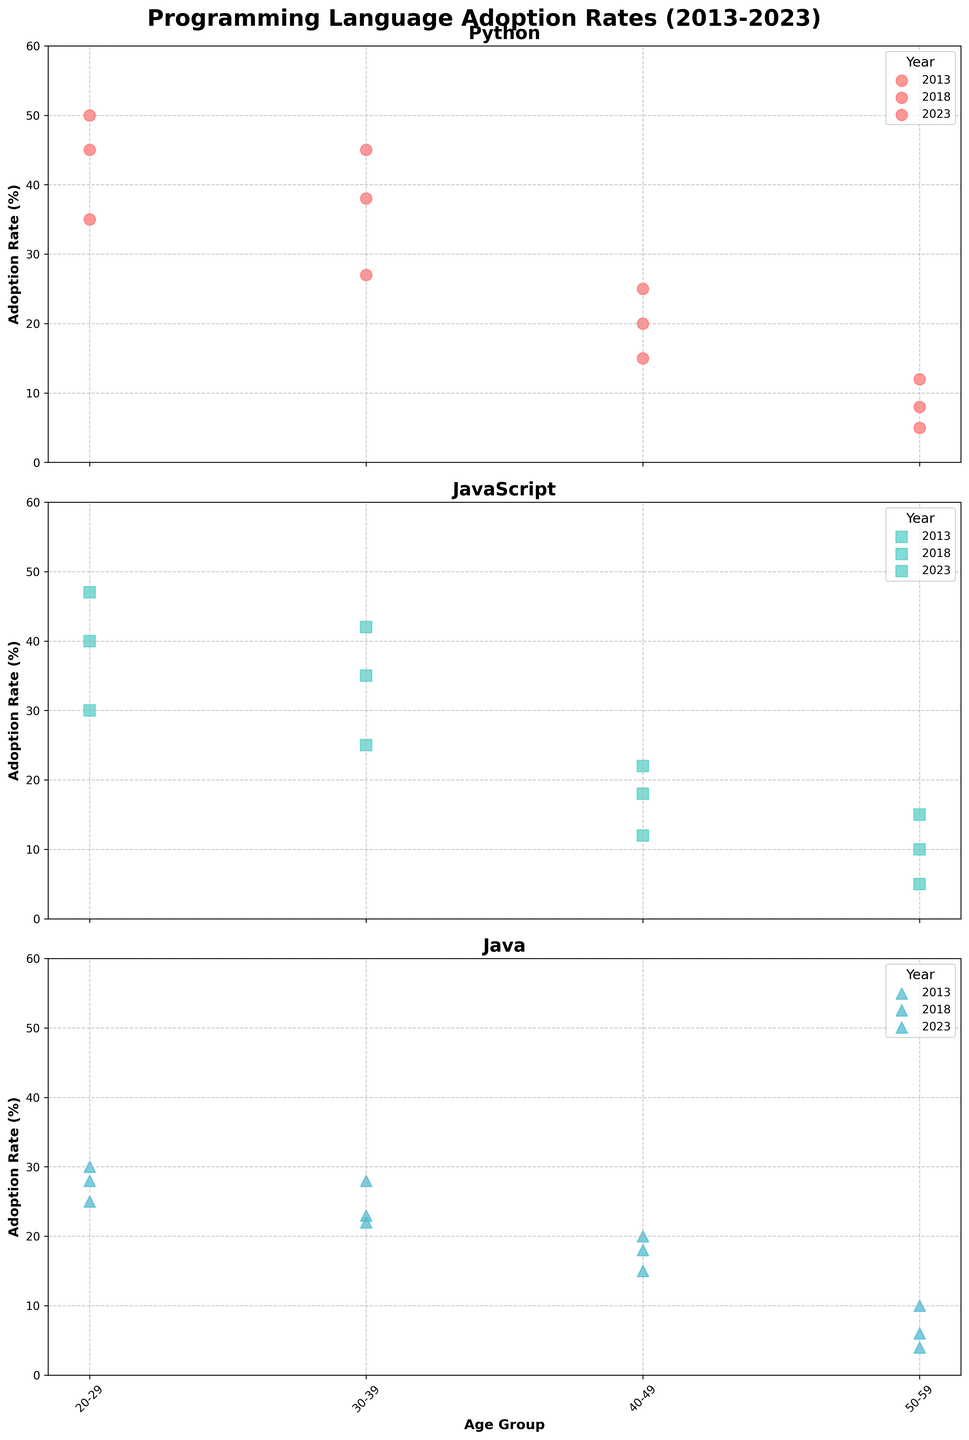What is the adoption rate of Python among the 20-29 age group in 2013? The Python subplot presents a data point for the 20-29 age group marked by a specific symbol for the year 2013. The adoption rate associated with this point represents the percentage.
Answer: 35 Between 2013 and 2023, which year shows the highest adoption rate for JavaScript in the 20-29 age group? Inspect the JavaScript subplot for the 20-29 age group. Compare the values from 2013, 2018, and 2023; selecting the highest.
Answer: 2023 What is the difference in adoption rates for Java in the 30-39 age group between 2013 and 2023? Locate the data points for the 30-39 age group in the Java subplot for both 2013 and 2023, then subtract the 2013 rate from the 2023 rate.
Answer: 6 Which language shows the highest adoption rate in the 50-59 age group in 2023? Look at the 2023 column in each subplot for the 50-59 age group, and find the highest value among them.
Answer: Python What is the average adoption rate of Python in the 20-29 age group across all three years? Sum the adoption rates for the 20-29 age group in Python across 2013, 2018, and 2023, then divide by the number of years (3). (35 + 45 + 50) / 3 = 43.33
Answer: 43.33 Compare the gender distribution in the Python subplot for 2018. Does one gender have a higher average adoption rate? For the year 2018 in the Python subplot, calculate the average of adoption rates for males and females separately, then compare.
Answer: Females (28.75 vs. 22) What has been the trend in JavaScript adoption rates for the 40-49 age group from 2013 to 2023? Inspect the JavaScript subplot for the 40-49 age group. Observe the changes in the adoption rates over 2013, 2018, and 2023.
Answer: Increasing Is there an age group where JavaScript and Java had the same adoption rate in any year? Examine all the subplots and look for common adoption rates for both JavaScript and Java in any age group within any given year.
Answer: No Which age group shows the most significant improvement in the adoption rate of Python from 2013 to 2018? Check each age group in the Python subplot for 2013 and 2018, calculate the difference, and choose the age group with the largest increase.
Answer: 20-29 (10) Across all languages, which age group consistently shows the lowest adoption rate in 2013? Review the data points for 2013 in each subplot across all age groups, and identify the age group with consistently low rates.
Answer: 50-59 